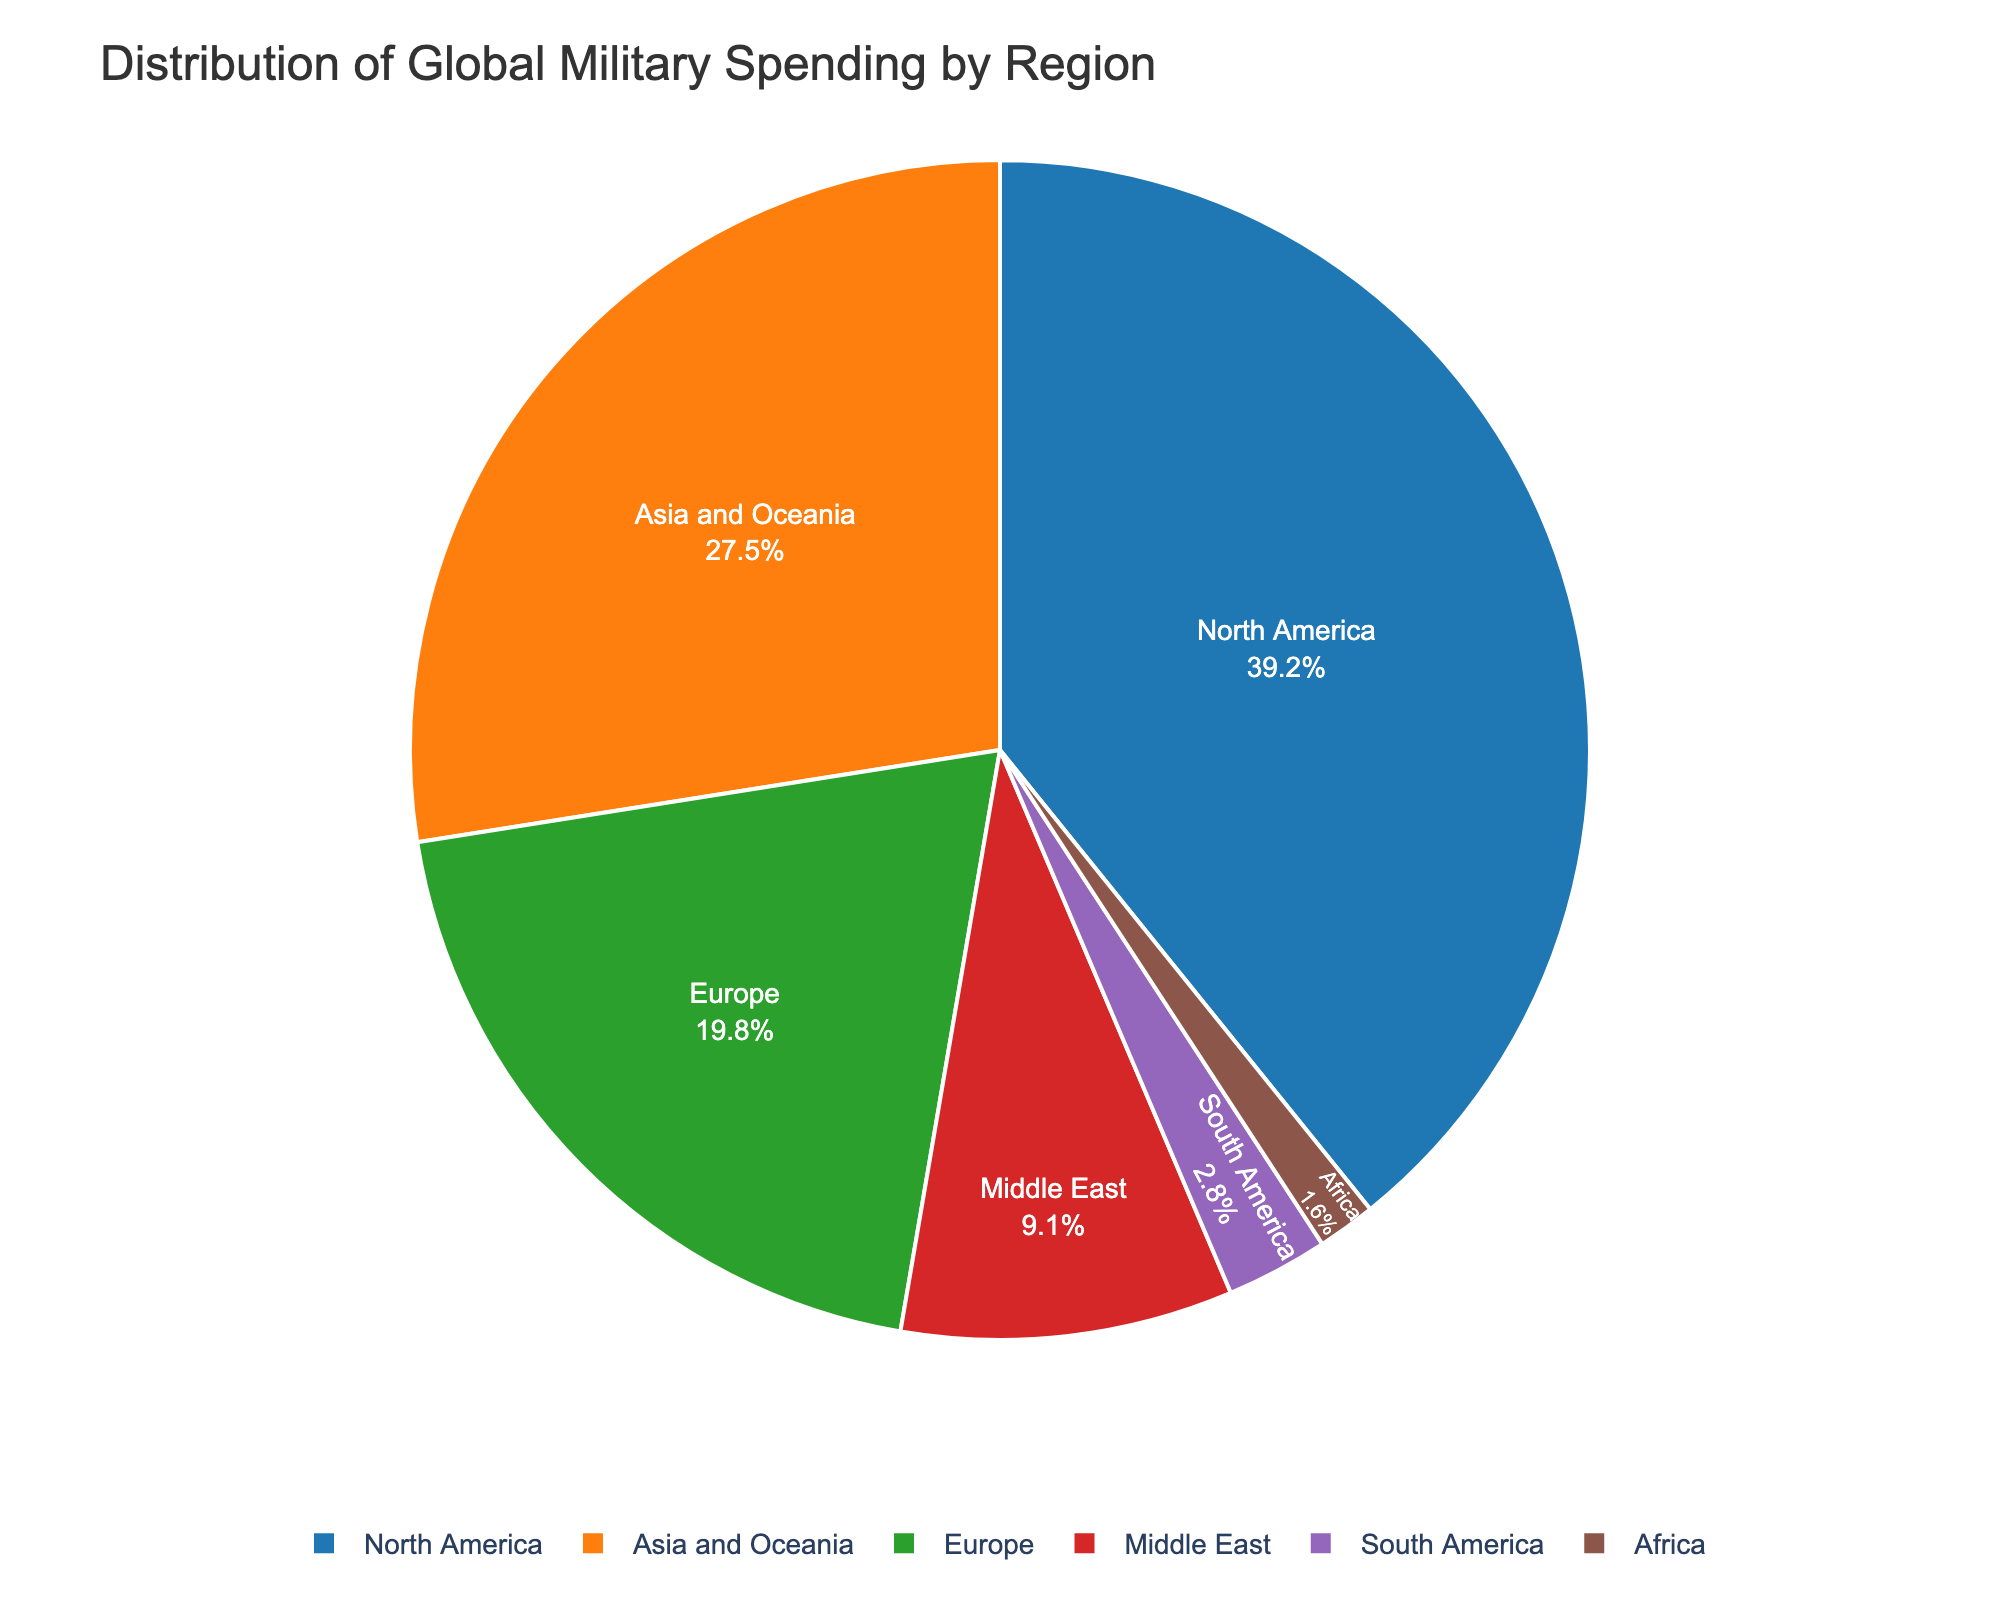What's the total percentage of military spending for North America and Europe? To find the total percentage, add the percentage values for North America and Europe. North America has 39.2% and Europe has 19.8%. So, 39.2 + 19.8 = 59.0%
Answer: 59.0% Which region contributes the least to global military spending? By observing the percentages for each region, we see that Africa has the smallest value at 1.6%.
Answer: Africa How much larger is the percentage of Asia and Oceania compared to South America? Subtract the percentage of South America from the percentage of Asia and Oceania. Asia and Oceania have 27.5% and South America has 2.8%. So, 27.5 - 2.8 = 24.7%
Answer: 24.7% What is the combined percentage of military spending for regions outside North America and Asia and Oceania? Add the percentages for Europe, the Middle East, South America, and Africa: 19.8% + 9.1% + 2.8% + 1.6% = 33.3%
Answer: 33.3% Which color represents Europe in the pie chart? By observing the custom colors assigned to regions, Europe is the third region, represented by the color green.
Answer: Green Among the regions, which two have percentage values closest to each other? By comparing values, Europe (19.8%) and the Middle East (9.1%) are not close. South America (2.8%) and Africa (1.6%) are the closest. The difference is 1.2% between South America and Africa.
Answer: South America and Africa If you combine the percentages of the three regions with the smallest military spending, what is the result? Add the percentages for the Middle East, South America, and Africa: 9.1% + 2.8% + 1.6% = 13.5%
Answer: 13.5% What is the average percentage of military spending across all regions? Add all percentages and divide by the number of regions: (39.2 + 27.5 + 19.8 + 9.1 + 2.8 + 1.6) / 6 = 100 / 6 = 16.67% approximately
Answer: 16.67% 